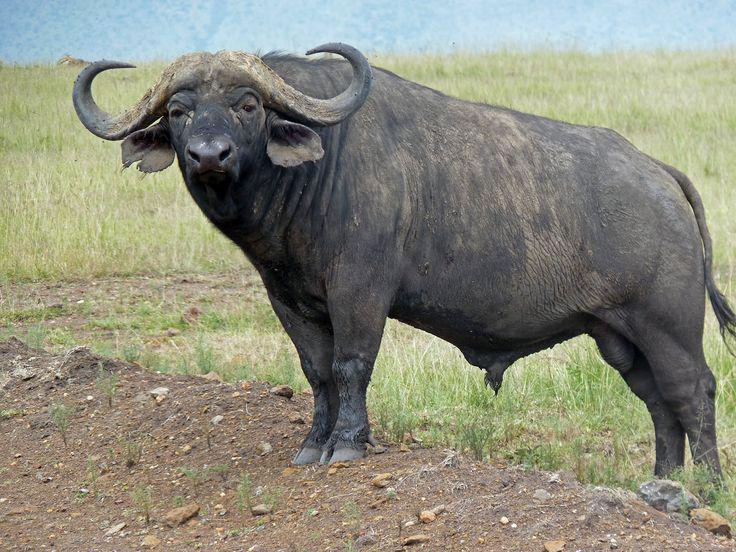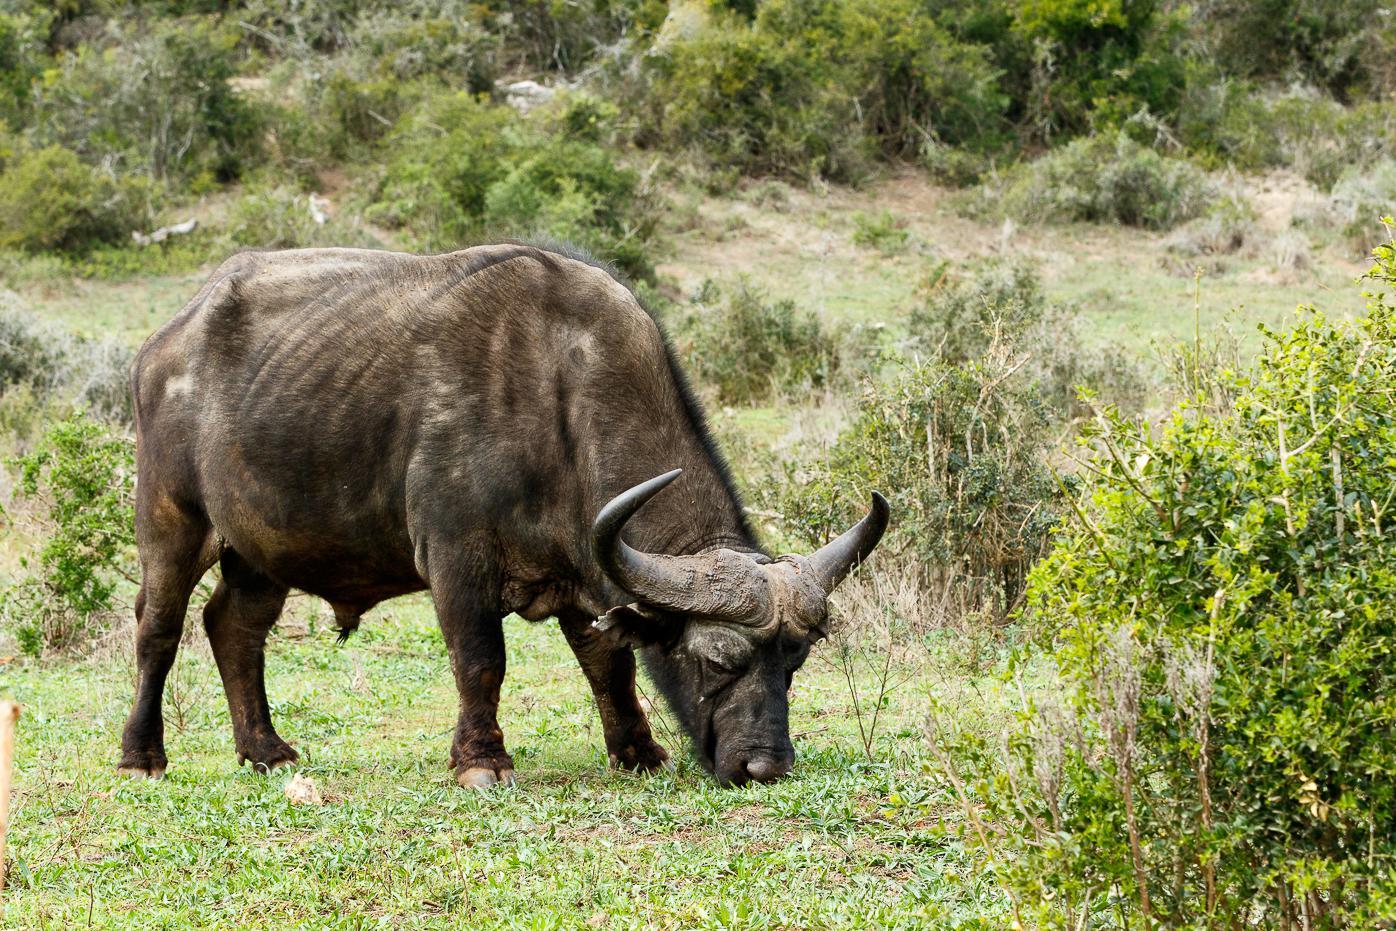The first image is the image on the left, the second image is the image on the right. Analyze the images presented: Is the assertion "The buffalo in the right image has its head down in the grass." valid? Answer yes or no. Yes. The first image is the image on the left, the second image is the image on the right. For the images shown, is this caption "An image shows exactly one water buffalo standing in wet area." true? Answer yes or no. No. 